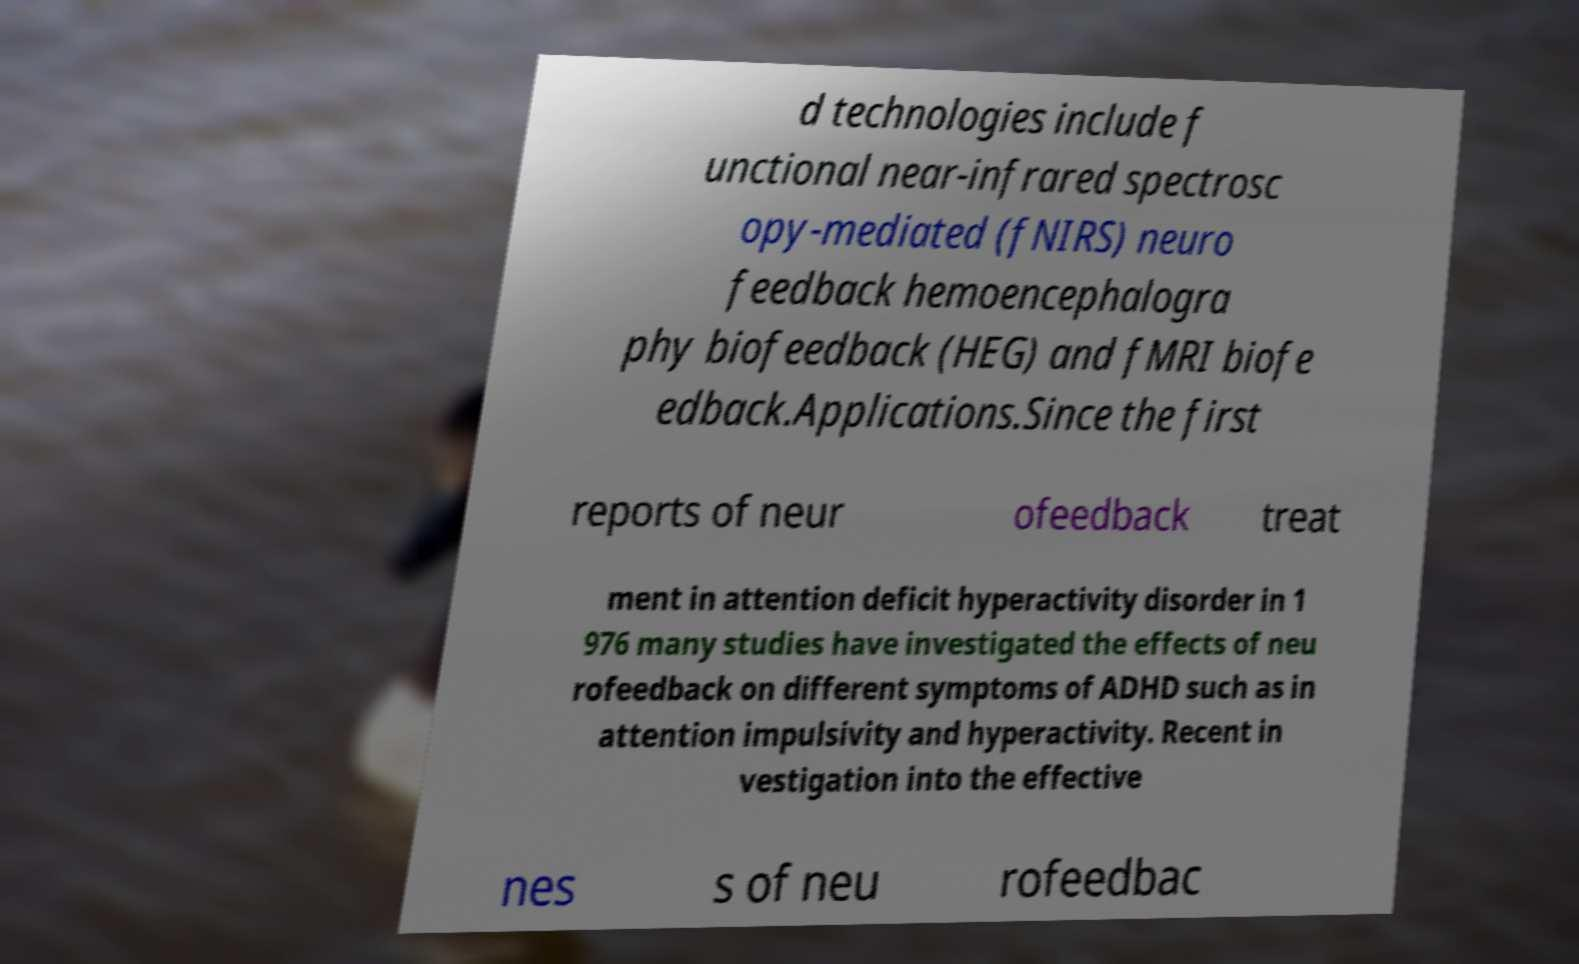Please read and relay the text visible in this image. What does it say? d technologies include f unctional near-infrared spectrosc opy-mediated (fNIRS) neuro feedback hemoencephalogra phy biofeedback (HEG) and fMRI biofe edback.Applications.Since the first reports of neur ofeedback treat ment in attention deficit hyperactivity disorder in 1 976 many studies have investigated the effects of neu rofeedback on different symptoms of ADHD such as in attention impulsivity and hyperactivity. Recent in vestigation into the effective nes s of neu rofeedbac 